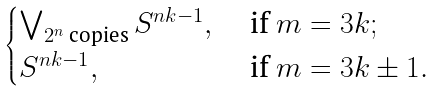<formula> <loc_0><loc_0><loc_500><loc_500>\begin{cases} \bigvee _ { 2 ^ { n } \text { copies} } S ^ { n k - 1 } , & \text { if } m = 3 k ; \\ S ^ { n k - 1 } , & \text { if } m = 3 k \pm 1 . \end{cases}</formula> 